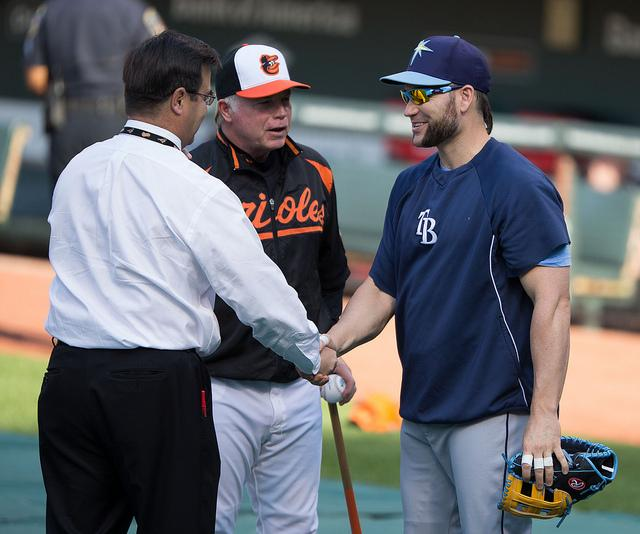Why are the men shaking hands? Please explain your reasoning. sportsmanship. They are being good sports. 